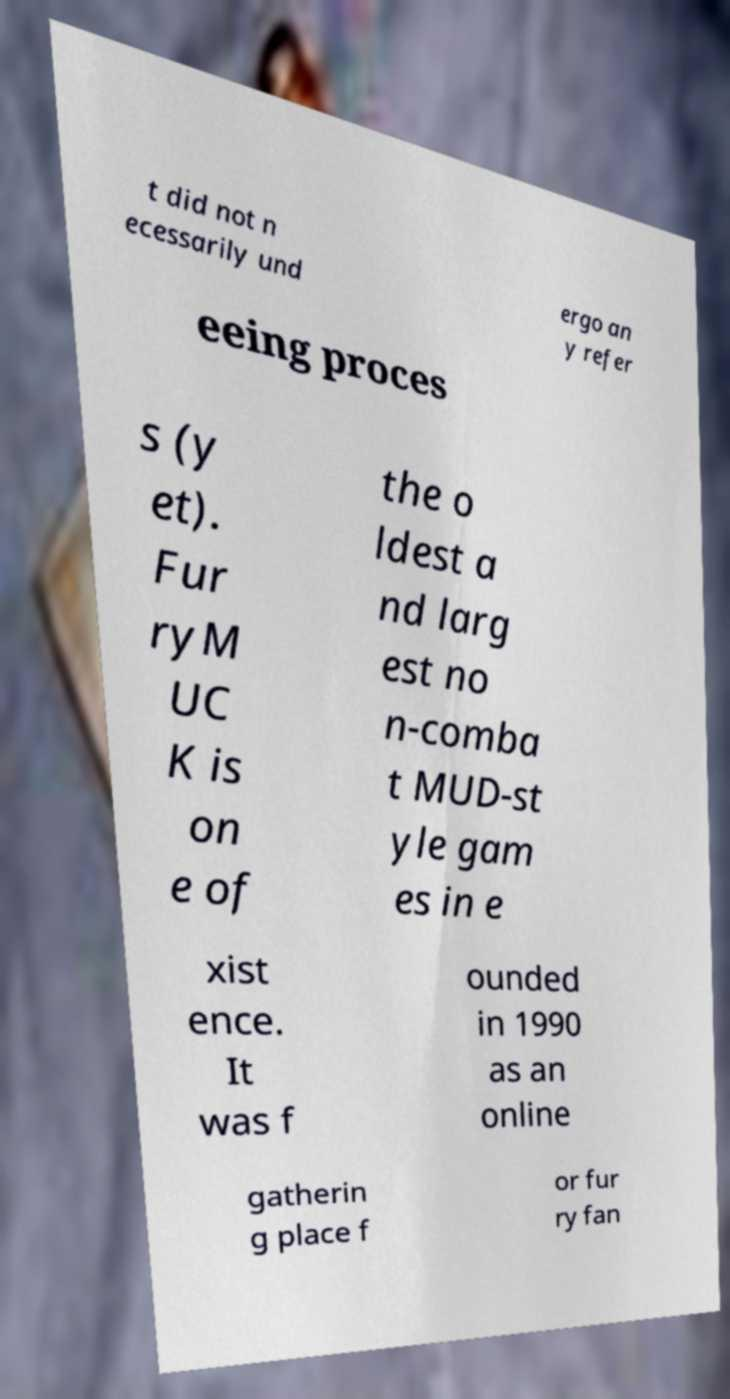Please read and relay the text visible in this image. What does it say? t did not n ecessarily und ergo an y refer eeing proces s (y et). Fur ryM UC K is on e of the o ldest a nd larg est no n-comba t MUD-st yle gam es in e xist ence. It was f ounded in 1990 as an online gatherin g place f or fur ry fan 